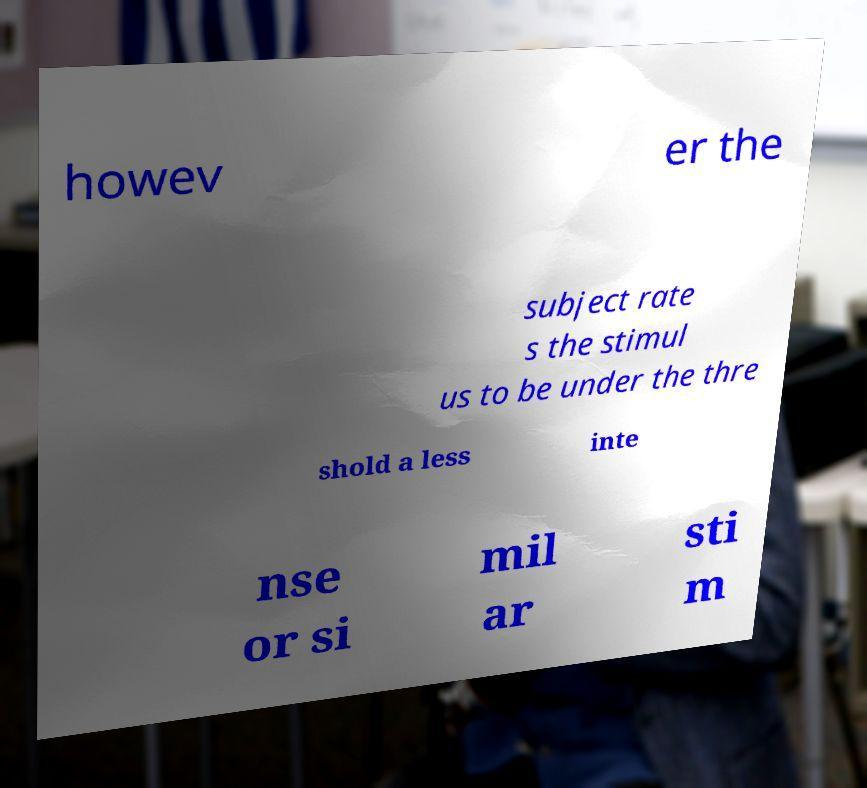I need the written content from this picture converted into text. Can you do that? howev er the subject rate s the stimul us to be under the thre shold a less inte nse or si mil ar sti m 